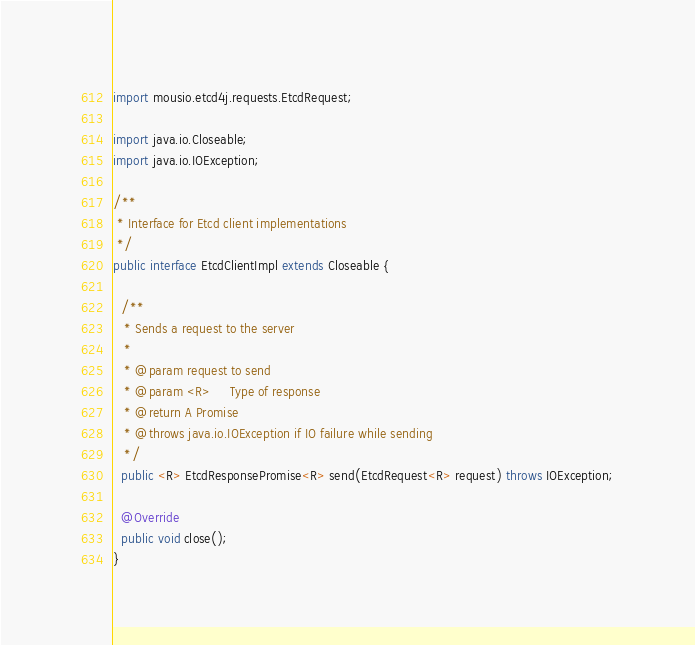<code> <loc_0><loc_0><loc_500><loc_500><_Java_>import mousio.etcd4j.requests.EtcdRequest;

import java.io.Closeable;
import java.io.IOException;

/**
 * Interface for Etcd client implementations
 */
public interface EtcdClientImpl extends Closeable {

  /**
   * Sends a request to the server
   *
   * @param request to send
   * @param <R>     Type of response
   * @return A Promise
   * @throws java.io.IOException if IO failure while sending
   */
  public <R> EtcdResponsePromise<R> send(EtcdRequest<R> request) throws IOException;

  @Override
  public void close();
}</code> 